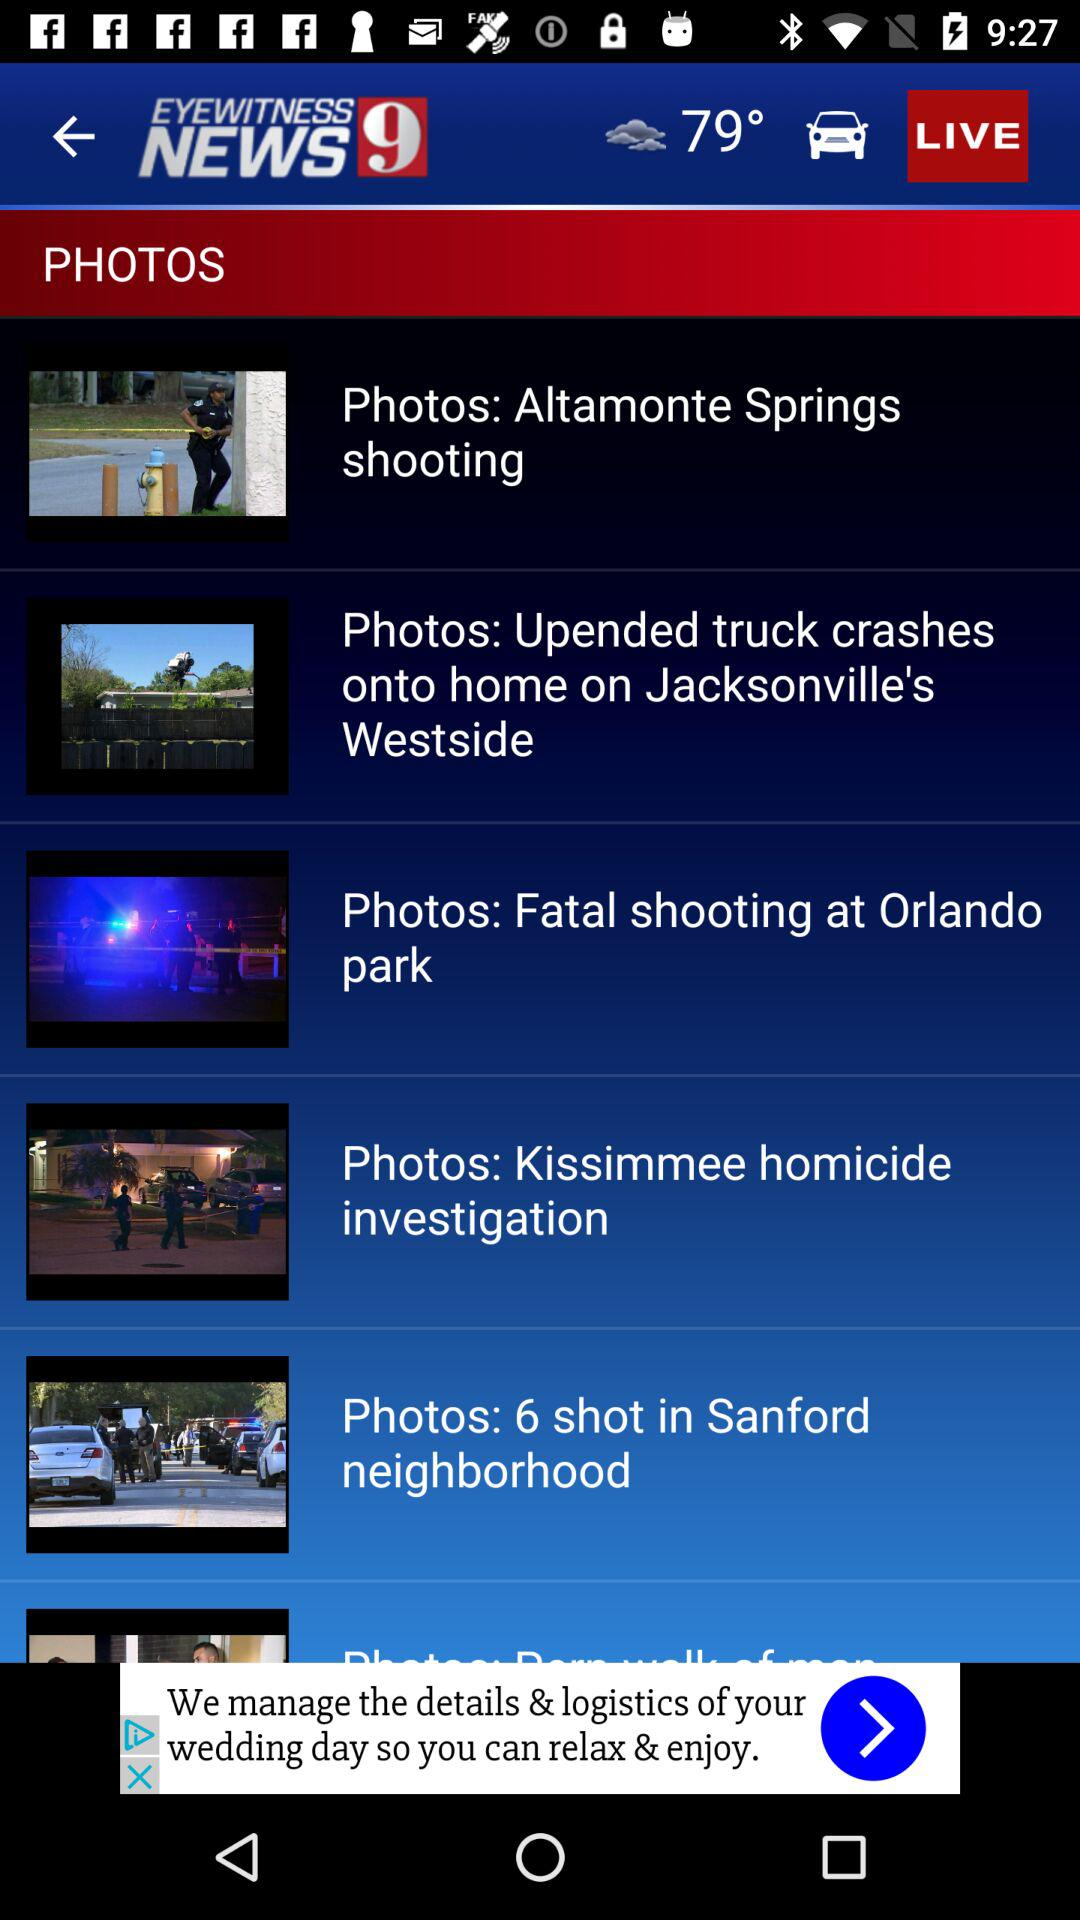What is the name of the application? The name of the application is "EYEWITNESS NEWS 9". 